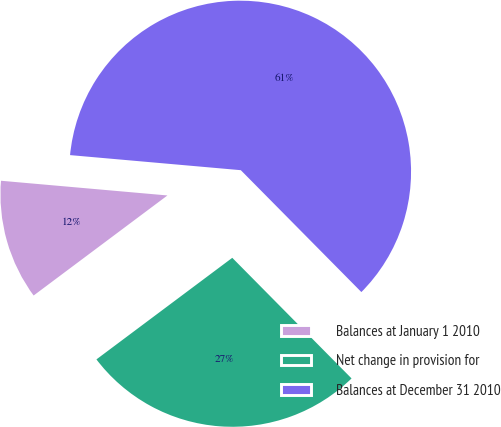<chart> <loc_0><loc_0><loc_500><loc_500><pie_chart><fcel>Balances at January 1 2010<fcel>Net change in provision for<fcel>Balances at December 31 2010<nl><fcel>11.62%<fcel>27.19%<fcel>61.18%<nl></chart> 